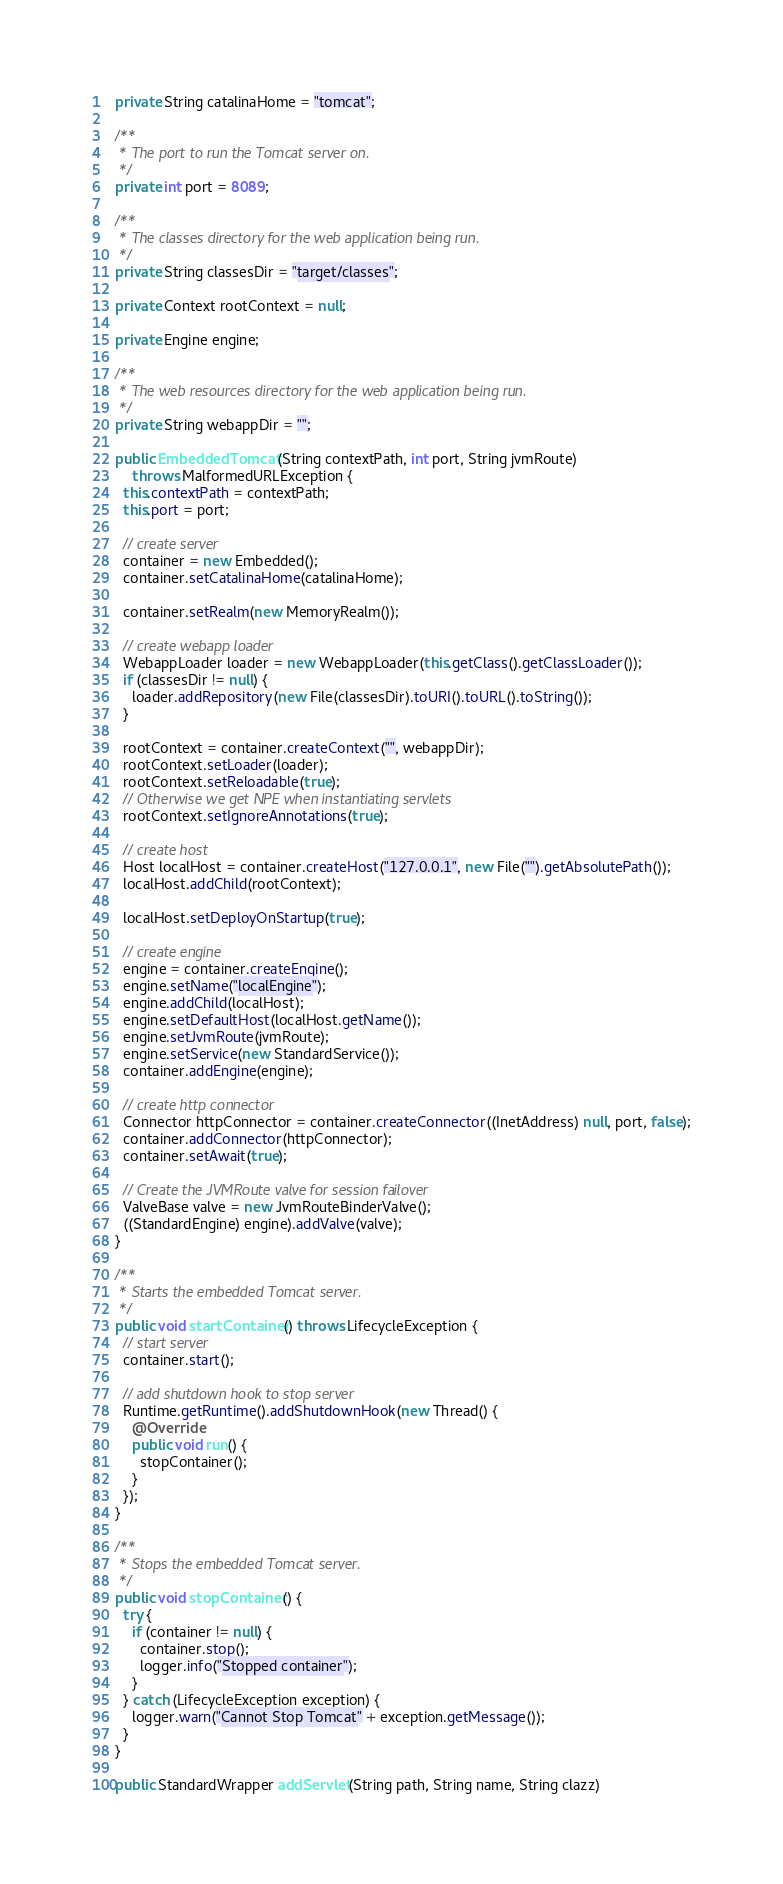Convert code to text. <code><loc_0><loc_0><loc_500><loc_500><_Java_>  private String catalinaHome = "tomcat";

  /**
   * The port to run the Tomcat server on.
   */
  private int port = 8089;

  /**
   * The classes directory for the web application being run.
   */
  private String classesDir = "target/classes";

  private Context rootContext = null;

  private Engine engine;

  /**
   * The web resources directory for the web application being run.
   */
  private String webappDir = "";

  public EmbeddedTomcat(String contextPath, int port, String jvmRoute)
      throws MalformedURLException {
    this.contextPath = contextPath;
    this.port = port;

    // create server
    container = new Embedded();
    container.setCatalinaHome(catalinaHome);

    container.setRealm(new MemoryRealm());

    // create webapp loader
    WebappLoader loader = new WebappLoader(this.getClass().getClassLoader());
    if (classesDir != null) {
      loader.addRepository(new File(classesDir).toURI().toURL().toString());
    }

    rootContext = container.createContext("", webappDir);
    rootContext.setLoader(loader);
    rootContext.setReloadable(true);
    // Otherwise we get NPE when instantiating servlets
    rootContext.setIgnoreAnnotations(true);

    // create host
    Host localHost = container.createHost("127.0.0.1", new File("").getAbsolutePath());
    localHost.addChild(rootContext);

    localHost.setDeployOnStartup(true);

    // create engine
    engine = container.createEngine();
    engine.setName("localEngine");
    engine.addChild(localHost);
    engine.setDefaultHost(localHost.getName());
    engine.setJvmRoute(jvmRoute);
    engine.setService(new StandardService());
    container.addEngine(engine);

    // create http connector
    Connector httpConnector = container.createConnector((InetAddress) null, port, false);
    container.addConnector(httpConnector);
    container.setAwait(true);

    // Create the JVMRoute valve for session failover
    ValveBase valve = new JvmRouteBinderValve();
    ((StandardEngine) engine).addValve(valve);
  }

  /**
   * Starts the embedded Tomcat server.
   */
  public void startContainer() throws LifecycleException {
    // start server
    container.start();

    // add shutdown hook to stop server
    Runtime.getRuntime().addShutdownHook(new Thread() {
      @Override
      public void run() {
        stopContainer();
      }
    });
  }

  /**
   * Stops the embedded Tomcat server.
   */
  public void stopContainer() {
    try {
      if (container != null) {
        container.stop();
        logger.info("Stopped container");
      }
    } catch (LifecycleException exception) {
      logger.warn("Cannot Stop Tomcat" + exception.getMessage());
    }
  }

  public StandardWrapper addServlet(String path, String name, String clazz)</code> 